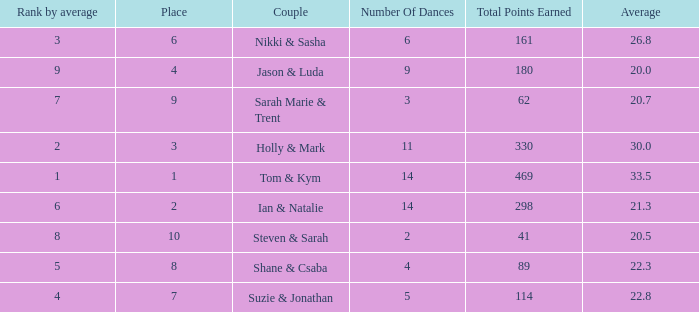What is the total points earned total number if the average is 21.3? 1.0. 